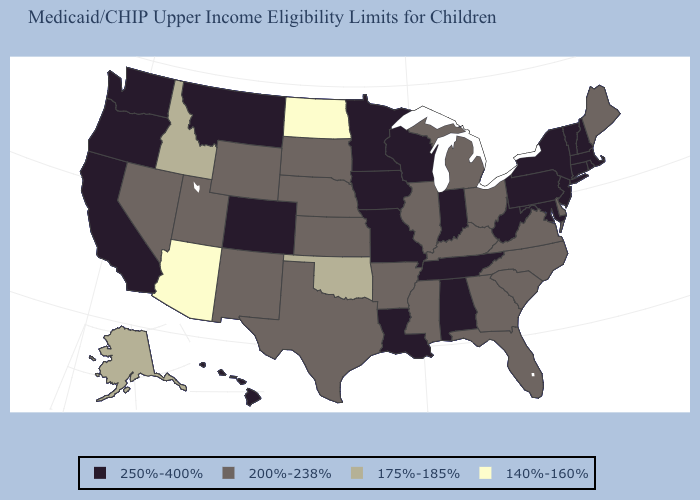Which states have the highest value in the USA?
Be succinct. Alabama, California, Colorado, Connecticut, Hawaii, Indiana, Iowa, Louisiana, Maryland, Massachusetts, Minnesota, Missouri, Montana, New Hampshire, New Jersey, New York, Oregon, Pennsylvania, Rhode Island, Tennessee, Vermont, Washington, West Virginia, Wisconsin. What is the value of Wyoming?
Short answer required. 200%-238%. Which states hav the highest value in the West?
Give a very brief answer. California, Colorado, Hawaii, Montana, Oregon, Washington. Name the states that have a value in the range 200%-238%?
Short answer required. Arkansas, Delaware, Florida, Georgia, Illinois, Kansas, Kentucky, Maine, Michigan, Mississippi, Nebraska, Nevada, New Mexico, North Carolina, Ohio, South Carolina, South Dakota, Texas, Utah, Virginia, Wyoming. Which states have the lowest value in the MidWest?
Write a very short answer. North Dakota. What is the lowest value in the USA?
Write a very short answer. 140%-160%. Which states have the highest value in the USA?
Keep it brief. Alabama, California, Colorado, Connecticut, Hawaii, Indiana, Iowa, Louisiana, Maryland, Massachusetts, Minnesota, Missouri, Montana, New Hampshire, New Jersey, New York, Oregon, Pennsylvania, Rhode Island, Tennessee, Vermont, Washington, West Virginia, Wisconsin. Name the states that have a value in the range 175%-185%?
Concise answer only. Alaska, Idaho, Oklahoma. Is the legend a continuous bar?
Write a very short answer. No. Which states have the lowest value in the Northeast?
Answer briefly. Maine. What is the lowest value in the USA?
Write a very short answer. 140%-160%. Name the states that have a value in the range 200%-238%?
Be succinct. Arkansas, Delaware, Florida, Georgia, Illinois, Kansas, Kentucky, Maine, Michigan, Mississippi, Nebraska, Nevada, New Mexico, North Carolina, Ohio, South Carolina, South Dakota, Texas, Utah, Virginia, Wyoming. Does Alabama have the highest value in the South?
Answer briefly. Yes. What is the lowest value in the USA?
Short answer required. 140%-160%. Among the states that border Michigan , which have the highest value?
Concise answer only. Indiana, Wisconsin. 